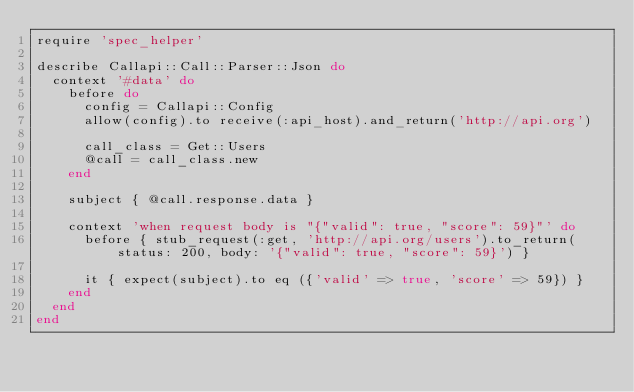Convert code to text. <code><loc_0><loc_0><loc_500><loc_500><_Ruby_>require 'spec_helper'

describe Callapi::Call::Parser::Json do
  context '#data' do
    before do
      config = Callapi::Config
      allow(config).to receive(:api_host).and_return('http://api.org')

      call_class = Get::Users
      @call = call_class.new
    end

    subject { @call.response.data }

    context 'when request body is "{"valid": true, "score": 59}"' do
      before { stub_request(:get, 'http://api.org/users').to_return(status: 200, body: '{"valid": true, "score": 59}') }

      it { expect(subject).to eq ({'valid' => true, 'score' => 59}) }
    end
  end
end</code> 